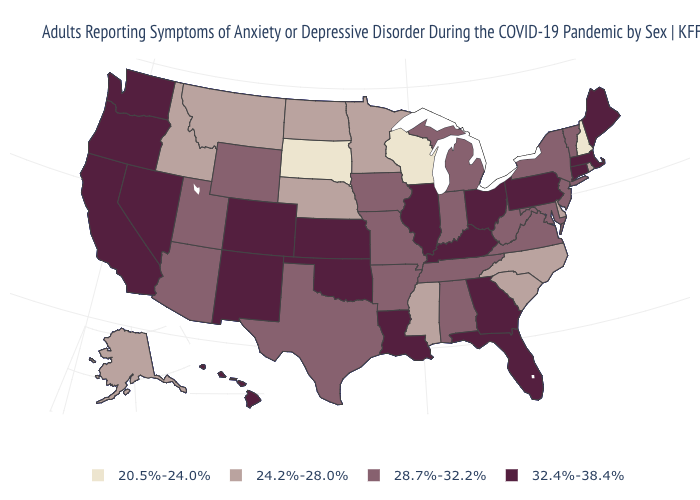Name the states that have a value in the range 20.5%-24.0%?
Give a very brief answer. New Hampshire, South Dakota, Wisconsin. Is the legend a continuous bar?
Answer briefly. No. Name the states that have a value in the range 28.7%-32.2%?
Concise answer only. Alabama, Arizona, Arkansas, Indiana, Iowa, Maryland, Michigan, Missouri, New Jersey, New York, Tennessee, Texas, Utah, Vermont, Virginia, West Virginia, Wyoming. Name the states that have a value in the range 32.4%-38.4%?
Quick response, please. California, Colorado, Connecticut, Florida, Georgia, Hawaii, Illinois, Kansas, Kentucky, Louisiana, Maine, Massachusetts, Nevada, New Mexico, Ohio, Oklahoma, Oregon, Pennsylvania, Washington. Which states have the lowest value in the USA?
Write a very short answer. New Hampshire, South Dakota, Wisconsin. Among the states that border New Hampshire , does Vermont have the lowest value?
Answer briefly. Yes. What is the value of Mississippi?
Answer briefly. 24.2%-28.0%. Among the states that border North Carolina , which have the highest value?
Quick response, please. Georgia. Name the states that have a value in the range 28.7%-32.2%?
Concise answer only. Alabama, Arizona, Arkansas, Indiana, Iowa, Maryland, Michigan, Missouri, New Jersey, New York, Tennessee, Texas, Utah, Vermont, Virginia, West Virginia, Wyoming. Name the states that have a value in the range 32.4%-38.4%?
Be succinct. California, Colorado, Connecticut, Florida, Georgia, Hawaii, Illinois, Kansas, Kentucky, Louisiana, Maine, Massachusetts, Nevada, New Mexico, Ohio, Oklahoma, Oregon, Pennsylvania, Washington. What is the value of Michigan?
Short answer required. 28.7%-32.2%. What is the value of Wisconsin?
Concise answer only. 20.5%-24.0%. How many symbols are there in the legend?
Concise answer only. 4. 